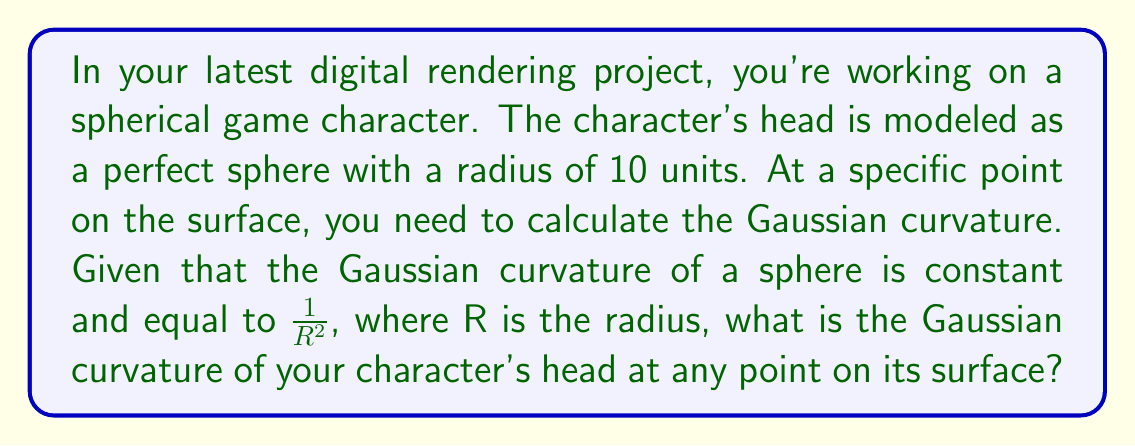Give your solution to this math problem. To calculate the Gaussian curvature of a sphere, we follow these steps:

1) Recall the formula for Gaussian curvature (K) of a sphere:
   
   $$K = \frac{1}{R^2}$$

   where R is the radius of the sphere.

2) In this case, we're given that the radius of the spherical head is 10 units.

3) Substitute R = 10 into the formula:

   $$K = \frac{1}{(10)^2} = \frac{1}{100}$$

4) Simplify:
   
   $$K = 0.01$$

Note: The units for Gaussian curvature are inverse square units, so in this case, it would be per square unit of whatever unit system you're using in your digital rendering.
Answer: $0.01$ per square unit 